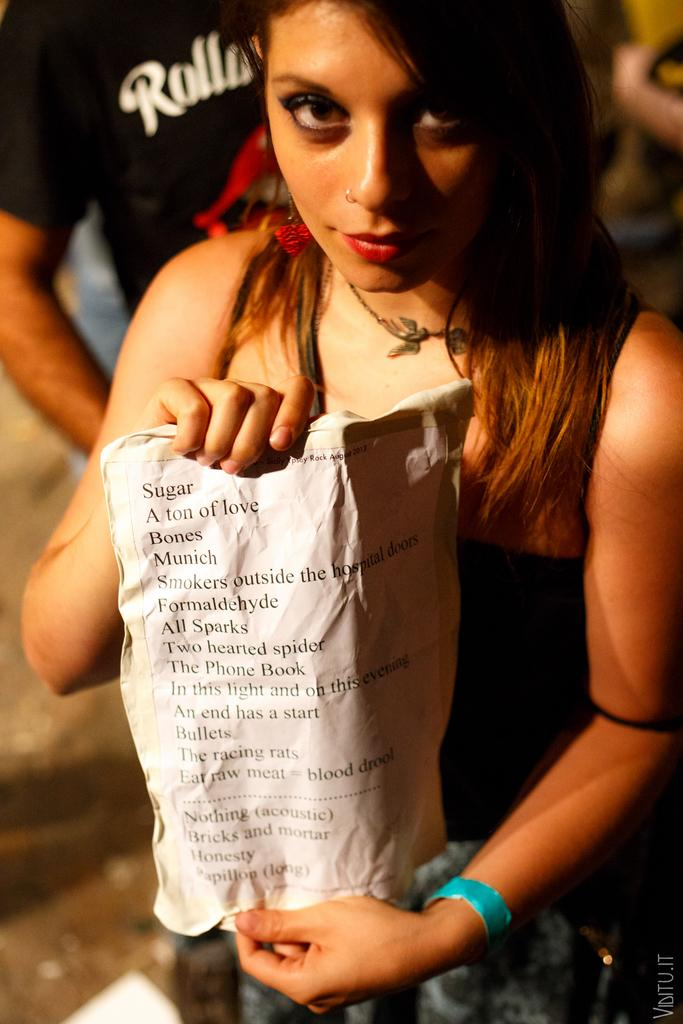What is the woman in the image doing? The woman is standing in the image. What is the woman holding in the image? The woman is holding a paper with some information on it. What is the woman wearing on her upper body? The woman is wearing a black top. Can you describe the other person in the image? The person is wearing a black T-shirt. How many brothers does the woman in the image have? There is no information about the woman's brothers in the image. What is the condition of the person's knee in the image? There is no information about the person's knee in the image. 